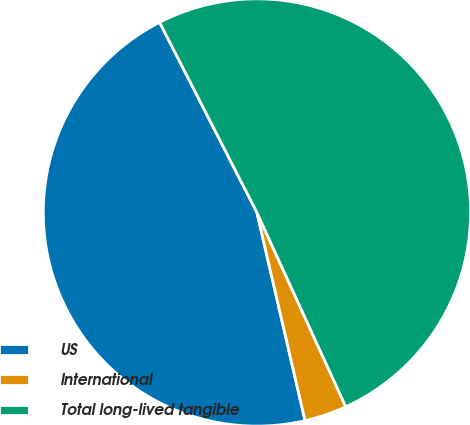Convert chart. <chart><loc_0><loc_0><loc_500><loc_500><pie_chart><fcel>US<fcel>International<fcel>Total long-lived tangible<nl><fcel>46.09%<fcel>3.21%<fcel>50.7%<nl></chart> 